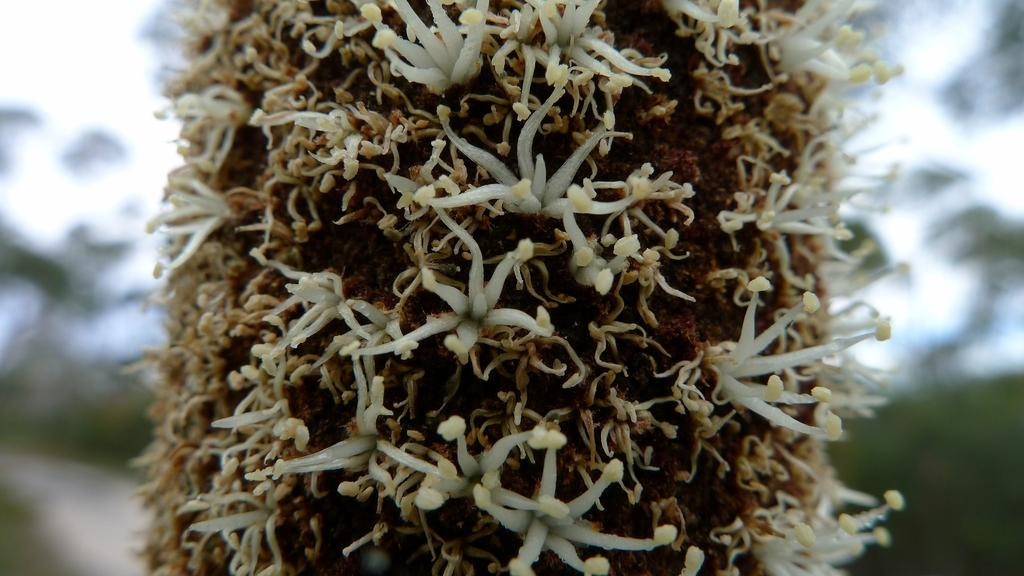What type of flowers are in the image? There are white color flowers in the image. Can you describe the background of the image? The background of the image is blurred. Can you see a frog sitting on the petals of the flowers in the image? There is no frog present in the image. Is the queen holding a pail while admiring the flowers in the image? There is no queen or pail present in the image. 